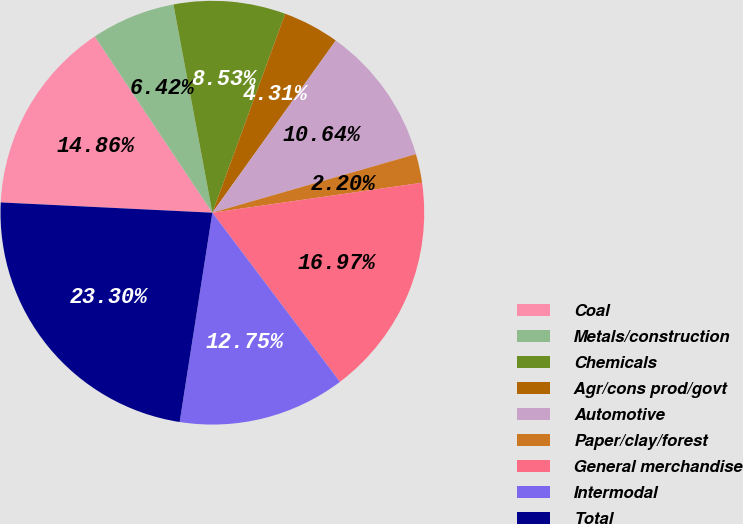Convert chart. <chart><loc_0><loc_0><loc_500><loc_500><pie_chart><fcel>Coal<fcel>Metals/construction<fcel>Chemicals<fcel>Agr/cons prod/govt<fcel>Automotive<fcel>Paper/clay/forest<fcel>General merchandise<fcel>Intermodal<fcel>Total<nl><fcel>14.86%<fcel>6.42%<fcel>8.53%<fcel>4.31%<fcel>10.64%<fcel>2.2%<fcel>16.97%<fcel>12.75%<fcel>23.3%<nl></chart> 